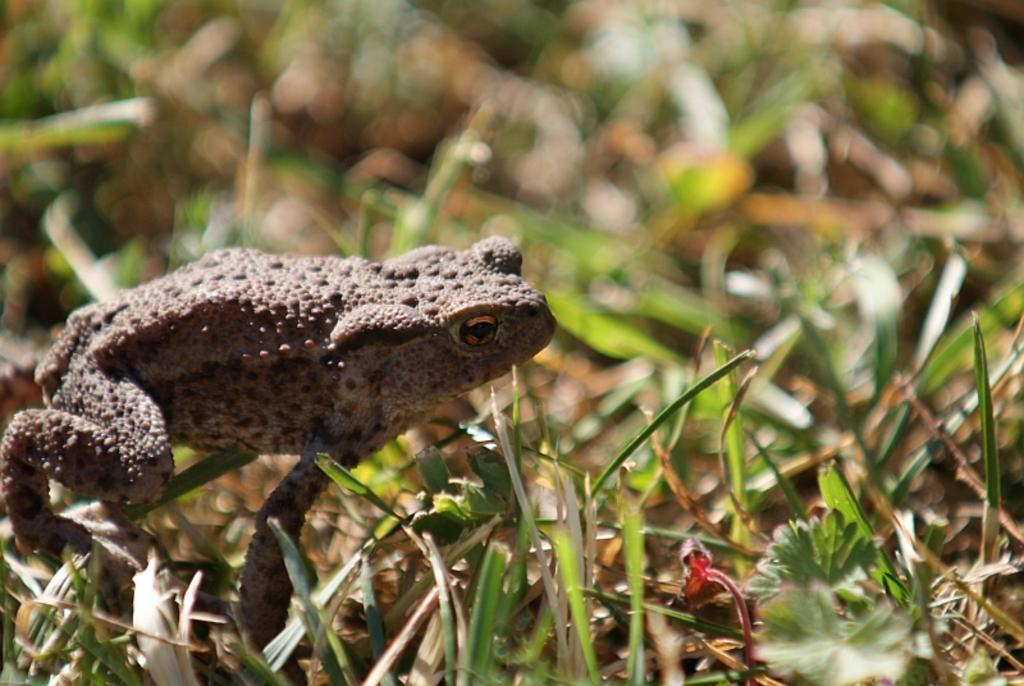What animal can be seen on the left side of the image? There is a frog on the left side of the image. What part of the image is not clear or in focus? The top part of the image is blurred. What type of vegetation is present in the foreground of the image? There is grass in the foreground of the image. Can you tell me which actor is performing in the image? There is no actor present in the image; it features a frog and grass. What type of zephyr can be seen blowing through the grass in the image? There is no zephyr present in the image; it is a still image of a frog and grass. 